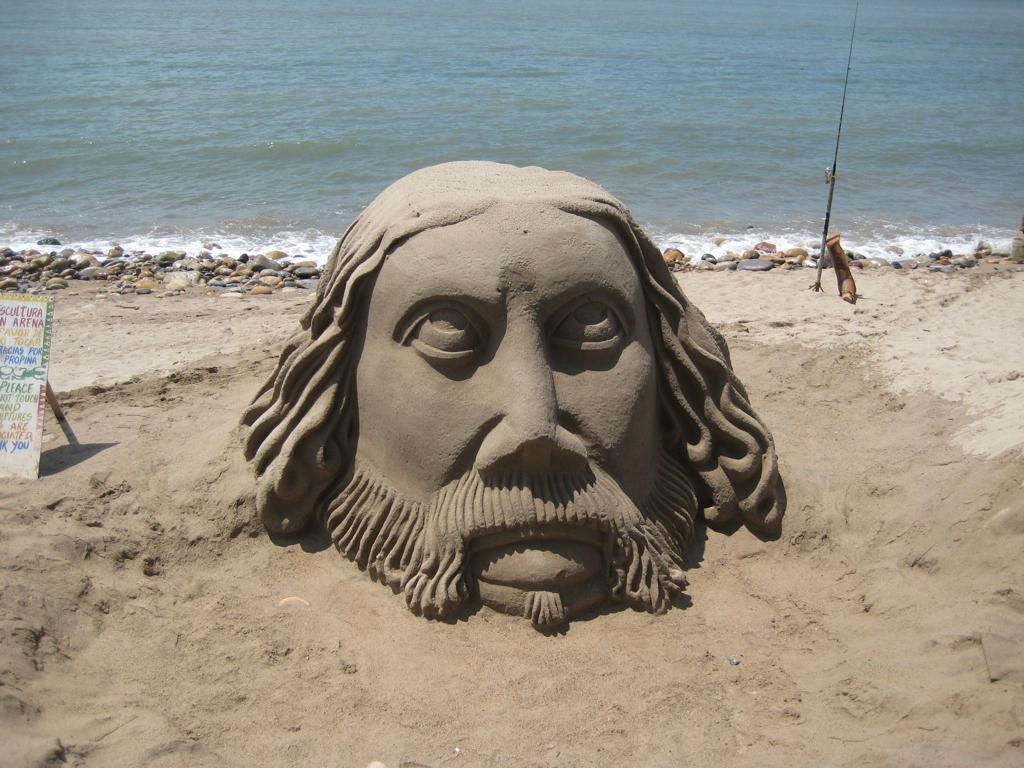What is the main subject of the image? There is sand art of a person's head in the image. What is located to the left of the sand art? There is a board to the left of the sand art. What can be seen in the background of the image? There are stones and water visible in the background of the image. Where is the library located in the image? There is no library present in the image. What type of note is attached to the sand art? There is no note attached to the sand art in the image. 